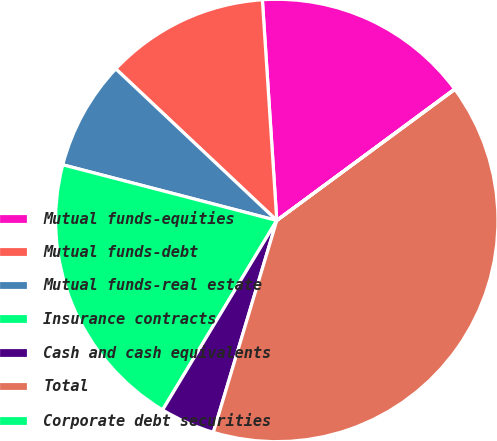Convert chart. <chart><loc_0><loc_0><loc_500><loc_500><pie_chart><fcel>Mutual funds-equities<fcel>Mutual funds-debt<fcel>Mutual funds-real estate<fcel>Insurance contracts<fcel>Cash and cash equivalents<fcel>Total<fcel>Corporate debt securities<nl><fcel>15.91%<fcel>11.94%<fcel>7.97%<fcel>20.42%<fcel>4.0%<fcel>39.73%<fcel>0.03%<nl></chart> 